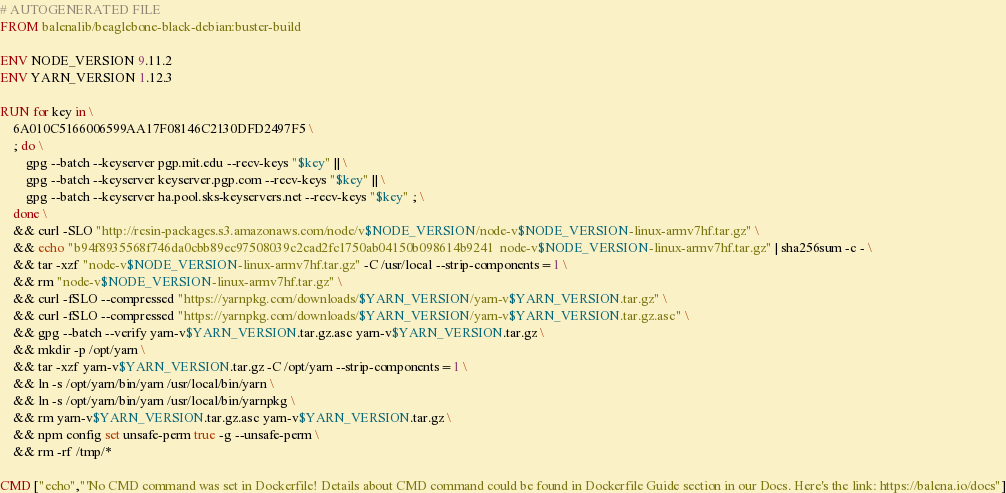<code> <loc_0><loc_0><loc_500><loc_500><_Dockerfile_># AUTOGENERATED FILE
FROM balenalib/beaglebone-black-debian:buster-build

ENV NODE_VERSION 9.11.2
ENV YARN_VERSION 1.12.3

RUN for key in \
	6A010C5166006599AA17F08146C2130DFD2497F5 \
	; do \
		gpg --batch --keyserver pgp.mit.edu --recv-keys "$key" || \
		gpg --batch --keyserver keyserver.pgp.com --recv-keys "$key" || \
		gpg --batch --keyserver ha.pool.sks-keyservers.net --recv-keys "$key" ; \
	done \
	&& curl -SLO "http://resin-packages.s3.amazonaws.com/node/v$NODE_VERSION/node-v$NODE_VERSION-linux-armv7hf.tar.gz" \
	&& echo "b94f8935568f746da0cbb89ec97508039c2cad2fc1750ab04150b098614b9241  node-v$NODE_VERSION-linux-armv7hf.tar.gz" | sha256sum -c - \
	&& tar -xzf "node-v$NODE_VERSION-linux-armv7hf.tar.gz" -C /usr/local --strip-components=1 \
	&& rm "node-v$NODE_VERSION-linux-armv7hf.tar.gz" \
	&& curl -fSLO --compressed "https://yarnpkg.com/downloads/$YARN_VERSION/yarn-v$YARN_VERSION.tar.gz" \
	&& curl -fSLO --compressed "https://yarnpkg.com/downloads/$YARN_VERSION/yarn-v$YARN_VERSION.tar.gz.asc" \
	&& gpg --batch --verify yarn-v$YARN_VERSION.tar.gz.asc yarn-v$YARN_VERSION.tar.gz \
	&& mkdir -p /opt/yarn \
	&& tar -xzf yarn-v$YARN_VERSION.tar.gz -C /opt/yarn --strip-components=1 \
	&& ln -s /opt/yarn/bin/yarn /usr/local/bin/yarn \
	&& ln -s /opt/yarn/bin/yarn /usr/local/bin/yarnpkg \
	&& rm yarn-v$YARN_VERSION.tar.gz.asc yarn-v$YARN_VERSION.tar.gz \
	&& npm config set unsafe-perm true -g --unsafe-perm \
	&& rm -rf /tmp/*

CMD ["echo","'No CMD command was set in Dockerfile! Details about CMD command could be found in Dockerfile Guide section in our Docs. Here's the link: https://balena.io/docs"]</code> 